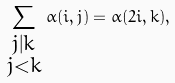Convert formula to latex. <formula><loc_0><loc_0><loc_500><loc_500>\sum _ { \begin{smallmatrix} j | k \\ j < k \end{smallmatrix} } \alpha ( i , j ) = \alpha ( 2 i , k ) ,</formula> 